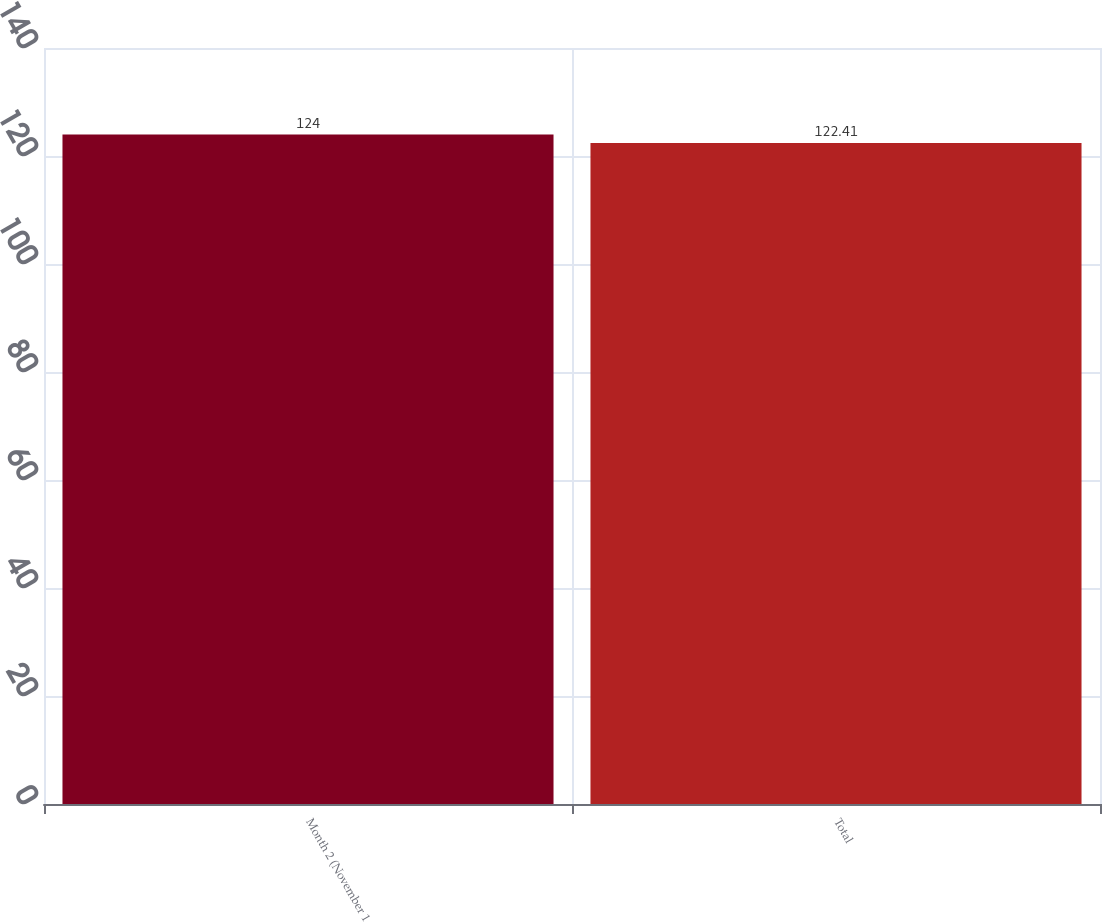<chart> <loc_0><loc_0><loc_500><loc_500><bar_chart><fcel>Month 2 (November 1<fcel>Total<nl><fcel>124<fcel>122.41<nl></chart> 